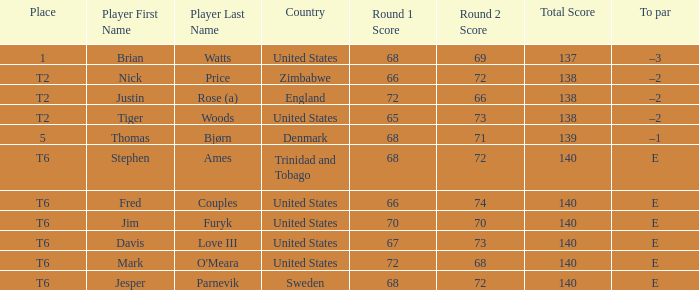In what place was Tiger Woods of the United States? T2. 